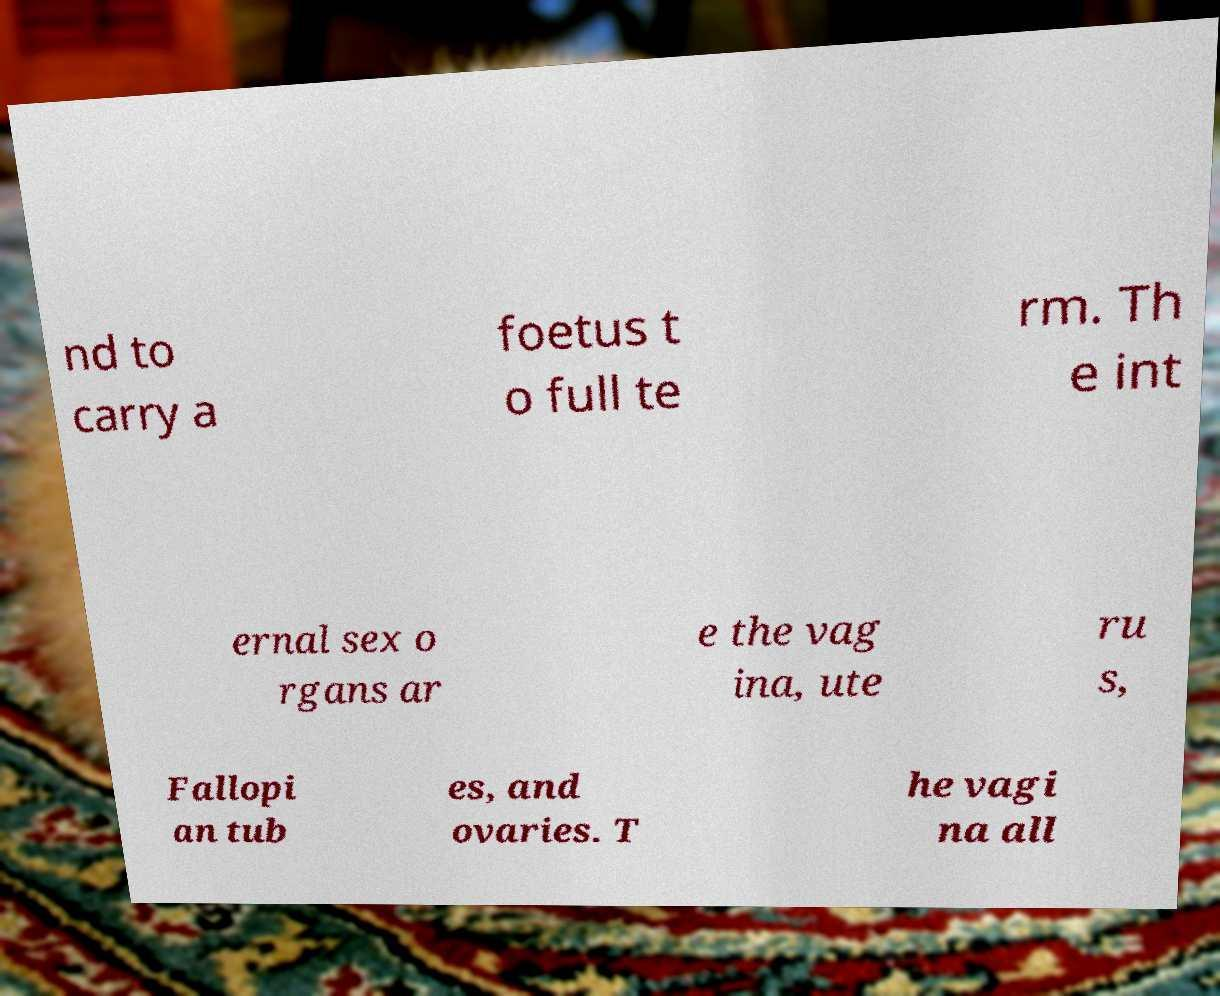There's text embedded in this image that I need extracted. Can you transcribe it verbatim? nd to carry a foetus t o full te rm. Th e int ernal sex o rgans ar e the vag ina, ute ru s, Fallopi an tub es, and ovaries. T he vagi na all 